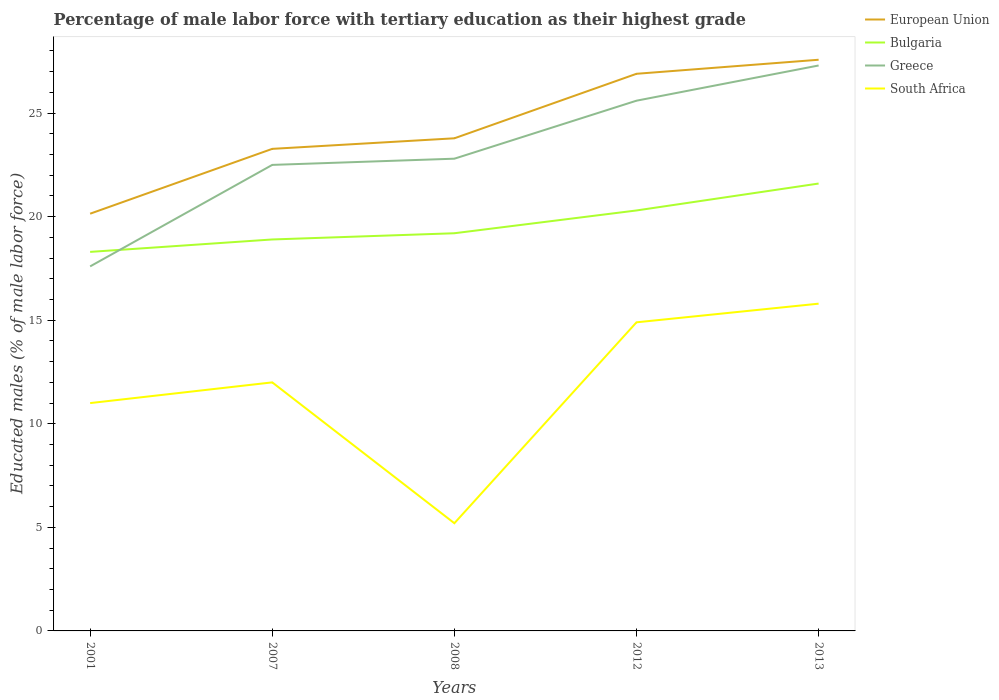How many different coloured lines are there?
Keep it short and to the point. 4. Across all years, what is the maximum percentage of male labor force with tertiary education in Greece?
Give a very brief answer. 17.6. In which year was the percentage of male labor force with tertiary education in Greece maximum?
Your answer should be compact. 2001. What is the total percentage of male labor force with tertiary education in European Union in the graph?
Provide a succinct answer. -6.75. What is the difference between the highest and the second highest percentage of male labor force with tertiary education in Greece?
Ensure brevity in your answer.  9.7. What is the difference between the highest and the lowest percentage of male labor force with tertiary education in European Union?
Offer a very short reply. 2. What is the title of the graph?
Your answer should be very brief. Percentage of male labor force with tertiary education as their highest grade. Does "Japan" appear as one of the legend labels in the graph?
Offer a very short reply. No. What is the label or title of the Y-axis?
Your response must be concise. Educated males (% of male labor force). What is the Educated males (% of male labor force) in European Union in 2001?
Ensure brevity in your answer.  20.14. What is the Educated males (% of male labor force) of Bulgaria in 2001?
Your answer should be very brief. 18.3. What is the Educated males (% of male labor force) of Greece in 2001?
Make the answer very short. 17.6. What is the Educated males (% of male labor force) of European Union in 2007?
Give a very brief answer. 23.27. What is the Educated males (% of male labor force) of Bulgaria in 2007?
Your response must be concise. 18.9. What is the Educated males (% of male labor force) in European Union in 2008?
Your answer should be very brief. 23.78. What is the Educated males (% of male labor force) of Bulgaria in 2008?
Keep it short and to the point. 19.2. What is the Educated males (% of male labor force) of Greece in 2008?
Offer a very short reply. 22.8. What is the Educated males (% of male labor force) in South Africa in 2008?
Keep it short and to the point. 5.2. What is the Educated males (% of male labor force) of European Union in 2012?
Provide a succinct answer. 26.9. What is the Educated males (% of male labor force) of Bulgaria in 2012?
Give a very brief answer. 20.3. What is the Educated males (% of male labor force) of Greece in 2012?
Keep it short and to the point. 25.6. What is the Educated males (% of male labor force) in South Africa in 2012?
Provide a succinct answer. 14.9. What is the Educated males (% of male labor force) of European Union in 2013?
Keep it short and to the point. 27.58. What is the Educated males (% of male labor force) in Bulgaria in 2013?
Offer a very short reply. 21.6. What is the Educated males (% of male labor force) in Greece in 2013?
Your answer should be very brief. 27.3. What is the Educated males (% of male labor force) of South Africa in 2013?
Provide a succinct answer. 15.8. Across all years, what is the maximum Educated males (% of male labor force) in European Union?
Give a very brief answer. 27.58. Across all years, what is the maximum Educated males (% of male labor force) of Bulgaria?
Make the answer very short. 21.6. Across all years, what is the maximum Educated males (% of male labor force) of Greece?
Your answer should be very brief. 27.3. Across all years, what is the maximum Educated males (% of male labor force) of South Africa?
Your answer should be very brief. 15.8. Across all years, what is the minimum Educated males (% of male labor force) of European Union?
Keep it short and to the point. 20.14. Across all years, what is the minimum Educated males (% of male labor force) of Bulgaria?
Provide a short and direct response. 18.3. Across all years, what is the minimum Educated males (% of male labor force) of Greece?
Provide a short and direct response. 17.6. Across all years, what is the minimum Educated males (% of male labor force) of South Africa?
Give a very brief answer. 5.2. What is the total Educated males (% of male labor force) in European Union in the graph?
Provide a short and direct response. 121.68. What is the total Educated males (% of male labor force) of Bulgaria in the graph?
Your answer should be very brief. 98.3. What is the total Educated males (% of male labor force) of Greece in the graph?
Keep it short and to the point. 115.8. What is the total Educated males (% of male labor force) in South Africa in the graph?
Make the answer very short. 58.9. What is the difference between the Educated males (% of male labor force) of European Union in 2001 and that in 2007?
Keep it short and to the point. -3.13. What is the difference between the Educated males (% of male labor force) in Bulgaria in 2001 and that in 2007?
Your response must be concise. -0.6. What is the difference between the Educated males (% of male labor force) of Greece in 2001 and that in 2007?
Provide a short and direct response. -4.9. What is the difference between the Educated males (% of male labor force) in South Africa in 2001 and that in 2007?
Your answer should be very brief. -1. What is the difference between the Educated males (% of male labor force) in European Union in 2001 and that in 2008?
Offer a terse response. -3.64. What is the difference between the Educated males (% of male labor force) in Greece in 2001 and that in 2008?
Your answer should be very brief. -5.2. What is the difference between the Educated males (% of male labor force) in South Africa in 2001 and that in 2008?
Your answer should be compact. 5.8. What is the difference between the Educated males (% of male labor force) of European Union in 2001 and that in 2012?
Your answer should be very brief. -6.75. What is the difference between the Educated males (% of male labor force) of Greece in 2001 and that in 2012?
Your response must be concise. -8. What is the difference between the Educated males (% of male labor force) of South Africa in 2001 and that in 2012?
Offer a very short reply. -3.9. What is the difference between the Educated males (% of male labor force) in European Union in 2001 and that in 2013?
Your answer should be very brief. -7.43. What is the difference between the Educated males (% of male labor force) in Bulgaria in 2001 and that in 2013?
Provide a succinct answer. -3.3. What is the difference between the Educated males (% of male labor force) of European Union in 2007 and that in 2008?
Your response must be concise. -0.51. What is the difference between the Educated males (% of male labor force) in Greece in 2007 and that in 2008?
Offer a very short reply. -0.3. What is the difference between the Educated males (% of male labor force) of European Union in 2007 and that in 2012?
Offer a very short reply. -3.62. What is the difference between the Educated males (% of male labor force) of Bulgaria in 2007 and that in 2012?
Offer a terse response. -1.4. What is the difference between the Educated males (% of male labor force) in Greece in 2007 and that in 2012?
Make the answer very short. -3.1. What is the difference between the Educated males (% of male labor force) in South Africa in 2007 and that in 2012?
Give a very brief answer. -2.9. What is the difference between the Educated males (% of male labor force) of European Union in 2007 and that in 2013?
Ensure brevity in your answer.  -4.3. What is the difference between the Educated males (% of male labor force) in Greece in 2007 and that in 2013?
Offer a terse response. -4.8. What is the difference between the Educated males (% of male labor force) of South Africa in 2007 and that in 2013?
Provide a short and direct response. -3.8. What is the difference between the Educated males (% of male labor force) in European Union in 2008 and that in 2012?
Make the answer very short. -3.11. What is the difference between the Educated males (% of male labor force) of Bulgaria in 2008 and that in 2012?
Your answer should be very brief. -1.1. What is the difference between the Educated males (% of male labor force) of South Africa in 2008 and that in 2012?
Make the answer very short. -9.7. What is the difference between the Educated males (% of male labor force) of European Union in 2008 and that in 2013?
Provide a succinct answer. -3.79. What is the difference between the Educated males (% of male labor force) in Bulgaria in 2008 and that in 2013?
Give a very brief answer. -2.4. What is the difference between the Educated males (% of male labor force) in European Union in 2012 and that in 2013?
Keep it short and to the point. -0.68. What is the difference between the Educated males (% of male labor force) in Bulgaria in 2012 and that in 2013?
Ensure brevity in your answer.  -1.3. What is the difference between the Educated males (% of male labor force) in South Africa in 2012 and that in 2013?
Keep it short and to the point. -0.9. What is the difference between the Educated males (% of male labor force) of European Union in 2001 and the Educated males (% of male labor force) of Bulgaria in 2007?
Provide a succinct answer. 1.24. What is the difference between the Educated males (% of male labor force) of European Union in 2001 and the Educated males (% of male labor force) of Greece in 2007?
Ensure brevity in your answer.  -2.36. What is the difference between the Educated males (% of male labor force) in European Union in 2001 and the Educated males (% of male labor force) in South Africa in 2007?
Provide a succinct answer. 8.14. What is the difference between the Educated males (% of male labor force) of Bulgaria in 2001 and the Educated males (% of male labor force) of Greece in 2007?
Your answer should be very brief. -4.2. What is the difference between the Educated males (% of male labor force) in European Union in 2001 and the Educated males (% of male labor force) in Bulgaria in 2008?
Provide a succinct answer. 0.94. What is the difference between the Educated males (% of male labor force) in European Union in 2001 and the Educated males (% of male labor force) in Greece in 2008?
Your answer should be compact. -2.66. What is the difference between the Educated males (% of male labor force) in European Union in 2001 and the Educated males (% of male labor force) in South Africa in 2008?
Your answer should be compact. 14.94. What is the difference between the Educated males (% of male labor force) of Greece in 2001 and the Educated males (% of male labor force) of South Africa in 2008?
Your answer should be very brief. 12.4. What is the difference between the Educated males (% of male labor force) of European Union in 2001 and the Educated males (% of male labor force) of Bulgaria in 2012?
Provide a succinct answer. -0.16. What is the difference between the Educated males (% of male labor force) of European Union in 2001 and the Educated males (% of male labor force) of Greece in 2012?
Your answer should be very brief. -5.46. What is the difference between the Educated males (% of male labor force) in European Union in 2001 and the Educated males (% of male labor force) in South Africa in 2012?
Offer a terse response. 5.24. What is the difference between the Educated males (% of male labor force) in European Union in 2001 and the Educated males (% of male labor force) in Bulgaria in 2013?
Your response must be concise. -1.46. What is the difference between the Educated males (% of male labor force) in European Union in 2001 and the Educated males (% of male labor force) in Greece in 2013?
Offer a very short reply. -7.16. What is the difference between the Educated males (% of male labor force) of European Union in 2001 and the Educated males (% of male labor force) of South Africa in 2013?
Your answer should be very brief. 4.34. What is the difference between the Educated males (% of male labor force) of Bulgaria in 2001 and the Educated males (% of male labor force) of South Africa in 2013?
Provide a short and direct response. 2.5. What is the difference between the Educated males (% of male labor force) in Greece in 2001 and the Educated males (% of male labor force) in South Africa in 2013?
Offer a very short reply. 1.8. What is the difference between the Educated males (% of male labor force) of European Union in 2007 and the Educated males (% of male labor force) of Bulgaria in 2008?
Keep it short and to the point. 4.07. What is the difference between the Educated males (% of male labor force) of European Union in 2007 and the Educated males (% of male labor force) of Greece in 2008?
Make the answer very short. 0.47. What is the difference between the Educated males (% of male labor force) of European Union in 2007 and the Educated males (% of male labor force) of South Africa in 2008?
Offer a terse response. 18.07. What is the difference between the Educated males (% of male labor force) in Bulgaria in 2007 and the Educated males (% of male labor force) in Greece in 2008?
Your answer should be compact. -3.9. What is the difference between the Educated males (% of male labor force) in European Union in 2007 and the Educated males (% of male labor force) in Bulgaria in 2012?
Give a very brief answer. 2.97. What is the difference between the Educated males (% of male labor force) in European Union in 2007 and the Educated males (% of male labor force) in Greece in 2012?
Offer a very short reply. -2.33. What is the difference between the Educated males (% of male labor force) of European Union in 2007 and the Educated males (% of male labor force) of South Africa in 2012?
Keep it short and to the point. 8.37. What is the difference between the Educated males (% of male labor force) of European Union in 2007 and the Educated males (% of male labor force) of Bulgaria in 2013?
Provide a short and direct response. 1.67. What is the difference between the Educated males (% of male labor force) of European Union in 2007 and the Educated males (% of male labor force) of Greece in 2013?
Provide a short and direct response. -4.03. What is the difference between the Educated males (% of male labor force) of European Union in 2007 and the Educated males (% of male labor force) of South Africa in 2013?
Offer a terse response. 7.47. What is the difference between the Educated males (% of male labor force) in Bulgaria in 2007 and the Educated males (% of male labor force) in Greece in 2013?
Make the answer very short. -8.4. What is the difference between the Educated males (% of male labor force) in Bulgaria in 2007 and the Educated males (% of male labor force) in South Africa in 2013?
Provide a succinct answer. 3.1. What is the difference between the Educated males (% of male labor force) in European Union in 2008 and the Educated males (% of male labor force) in Bulgaria in 2012?
Offer a very short reply. 3.48. What is the difference between the Educated males (% of male labor force) in European Union in 2008 and the Educated males (% of male labor force) in Greece in 2012?
Make the answer very short. -1.82. What is the difference between the Educated males (% of male labor force) in European Union in 2008 and the Educated males (% of male labor force) in South Africa in 2012?
Make the answer very short. 8.88. What is the difference between the Educated males (% of male labor force) in Bulgaria in 2008 and the Educated males (% of male labor force) in South Africa in 2012?
Ensure brevity in your answer.  4.3. What is the difference between the Educated males (% of male labor force) of Greece in 2008 and the Educated males (% of male labor force) of South Africa in 2012?
Offer a terse response. 7.9. What is the difference between the Educated males (% of male labor force) of European Union in 2008 and the Educated males (% of male labor force) of Bulgaria in 2013?
Your answer should be compact. 2.18. What is the difference between the Educated males (% of male labor force) in European Union in 2008 and the Educated males (% of male labor force) in Greece in 2013?
Your response must be concise. -3.52. What is the difference between the Educated males (% of male labor force) of European Union in 2008 and the Educated males (% of male labor force) of South Africa in 2013?
Offer a very short reply. 7.98. What is the difference between the Educated males (% of male labor force) of Bulgaria in 2008 and the Educated males (% of male labor force) of South Africa in 2013?
Ensure brevity in your answer.  3.4. What is the difference between the Educated males (% of male labor force) of European Union in 2012 and the Educated males (% of male labor force) of Bulgaria in 2013?
Provide a succinct answer. 5.3. What is the difference between the Educated males (% of male labor force) of European Union in 2012 and the Educated males (% of male labor force) of Greece in 2013?
Give a very brief answer. -0.4. What is the difference between the Educated males (% of male labor force) of European Union in 2012 and the Educated males (% of male labor force) of South Africa in 2013?
Your response must be concise. 11.1. What is the difference between the Educated males (% of male labor force) in Bulgaria in 2012 and the Educated males (% of male labor force) in South Africa in 2013?
Your answer should be very brief. 4.5. What is the average Educated males (% of male labor force) of European Union per year?
Your response must be concise. 24.34. What is the average Educated males (% of male labor force) in Bulgaria per year?
Offer a very short reply. 19.66. What is the average Educated males (% of male labor force) in Greece per year?
Make the answer very short. 23.16. What is the average Educated males (% of male labor force) in South Africa per year?
Provide a short and direct response. 11.78. In the year 2001, what is the difference between the Educated males (% of male labor force) in European Union and Educated males (% of male labor force) in Bulgaria?
Offer a very short reply. 1.84. In the year 2001, what is the difference between the Educated males (% of male labor force) in European Union and Educated males (% of male labor force) in Greece?
Offer a very short reply. 2.54. In the year 2001, what is the difference between the Educated males (% of male labor force) of European Union and Educated males (% of male labor force) of South Africa?
Your answer should be compact. 9.14. In the year 2007, what is the difference between the Educated males (% of male labor force) of European Union and Educated males (% of male labor force) of Bulgaria?
Offer a very short reply. 4.37. In the year 2007, what is the difference between the Educated males (% of male labor force) in European Union and Educated males (% of male labor force) in Greece?
Offer a terse response. 0.77. In the year 2007, what is the difference between the Educated males (% of male labor force) of European Union and Educated males (% of male labor force) of South Africa?
Provide a succinct answer. 11.27. In the year 2007, what is the difference between the Educated males (% of male labor force) of Bulgaria and Educated males (% of male labor force) of Greece?
Give a very brief answer. -3.6. In the year 2007, what is the difference between the Educated males (% of male labor force) in Bulgaria and Educated males (% of male labor force) in South Africa?
Offer a very short reply. 6.9. In the year 2007, what is the difference between the Educated males (% of male labor force) in Greece and Educated males (% of male labor force) in South Africa?
Your response must be concise. 10.5. In the year 2008, what is the difference between the Educated males (% of male labor force) in European Union and Educated males (% of male labor force) in Bulgaria?
Keep it short and to the point. 4.58. In the year 2008, what is the difference between the Educated males (% of male labor force) in European Union and Educated males (% of male labor force) in Greece?
Your answer should be very brief. 0.98. In the year 2008, what is the difference between the Educated males (% of male labor force) of European Union and Educated males (% of male labor force) of South Africa?
Provide a succinct answer. 18.58. In the year 2008, what is the difference between the Educated males (% of male labor force) in Bulgaria and Educated males (% of male labor force) in Greece?
Provide a short and direct response. -3.6. In the year 2012, what is the difference between the Educated males (% of male labor force) of European Union and Educated males (% of male labor force) of Bulgaria?
Offer a very short reply. 6.6. In the year 2012, what is the difference between the Educated males (% of male labor force) in European Union and Educated males (% of male labor force) in Greece?
Your answer should be compact. 1.3. In the year 2012, what is the difference between the Educated males (% of male labor force) in European Union and Educated males (% of male labor force) in South Africa?
Provide a succinct answer. 12. In the year 2012, what is the difference between the Educated males (% of male labor force) in Greece and Educated males (% of male labor force) in South Africa?
Give a very brief answer. 10.7. In the year 2013, what is the difference between the Educated males (% of male labor force) of European Union and Educated males (% of male labor force) of Bulgaria?
Offer a very short reply. 5.98. In the year 2013, what is the difference between the Educated males (% of male labor force) of European Union and Educated males (% of male labor force) of Greece?
Provide a short and direct response. 0.28. In the year 2013, what is the difference between the Educated males (% of male labor force) of European Union and Educated males (% of male labor force) of South Africa?
Make the answer very short. 11.78. In the year 2013, what is the difference between the Educated males (% of male labor force) of Bulgaria and Educated males (% of male labor force) of South Africa?
Offer a very short reply. 5.8. What is the ratio of the Educated males (% of male labor force) in European Union in 2001 to that in 2007?
Provide a succinct answer. 0.87. What is the ratio of the Educated males (% of male labor force) in Bulgaria in 2001 to that in 2007?
Your answer should be compact. 0.97. What is the ratio of the Educated males (% of male labor force) of Greece in 2001 to that in 2007?
Provide a short and direct response. 0.78. What is the ratio of the Educated males (% of male labor force) in South Africa in 2001 to that in 2007?
Your response must be concise. 0.92. What is the ratio of the Educated males (% of male labor force) of European Union in 2001 to that in 2008?
Your answer should be compact. 0.85. What is the ratio of the Educated males (% of male labor force) in Bulgaria in 2001 to that in 2008?
Offer a very short reply. 0.95. What is the ratio of the Educated males (% of male labor force) in Greece in 2001 to that in 2008?
Your answer should be compact. 0.77. What is the ratio of the Educated males (% of male labor force) in South Africa in 2001 to that in 2008?
Offer a very short reply. 2.12. What is the ratio of the Educated males (% of male labor force) in European Union in 2001 to that in 2012?
Your answer should be very brief. 0.75. What is the ratio of the Educated males (% of male labor force) of Bulgaria in 2001 to that in 2012?
Keep it short and to the point. 0.9. What is the ratio of the Educated males (% of male labor force) of Greece in 2001 to that in 2012?
Your answer should be compact. 0.69. What is the ratio of the Educated males (% of male labor force) in South Africa in 2001 to that in 2012?
Your answer should be compact. 0.74. What is the ratio of the Educated males (% of male labor force) in European Union in 2001 to that in 2013?
Provide a succinct answer. 0.73. What is the ratio of the Educated males (% of male labor force) of Bulgaria in 2001 to that in 2013?
Your response must be concise. 0.85. What is the ratio of the Educated males (% of male labor force) of Greece in 2001 to that in 2013?
Offer a terse response. 0.64. What is the ratio of the Educated males (% of male labor force) of South Africa in 2001 to that in 2013?
Your answer should be compact. 0.7. What is the ratio of the Educated males (% of male labor force) in European Union in 2007 to that in 2008?
Offer a very short reply. 0.98. What is the ratio of the Educated males (% of male labor force) in Bulgaria in 2007 to that in 2008?
Your answer should be very brief. 0.98. What is the ratio of the Educated males (% of male labor force) in South Africa in 2007 to that in 2008?
Give a very brief answer. 2.31. What is the ratio of the Educated males (% of male labor force) in European Union in 2007 to that in 2012?
Ensure brevity in your answer.  0.87. What is the ratio of the Educated males (% of male labor force) of Bulgaria in 2007 to that in 2012?
Ensure brevity in your answer.  0.93. What is the ratio of the Educated males (% of male labor force) in Greece in 2007 to that in 2012?
Offer a terse response. 0.88. What is the ratio of the Educated males (% of male labor force) of South Africa in 2007 to that in 2012?
Give a very brief answer. 0.81. What is the ratio of the Educated males (% of male labor force) in European Union in 2007 to that in 2013?
Your answer should be very brief. 0.84. What is the ratio of the Educated males (% of male labor force) of Greece in 2007 to that in 2013?
Make the answer very short. 0.82. What is the ratio of the Educated males (% of male labor force) in South Africa in 2007 to that in 2013?
Keep it short and to the point. 0.76. What is the ratio of the Educated males (% of male labor force) of European Union in 2008 to that in 2012?
Offer a terse response. 0.88. What is the ratio of the Educated males (% of male labor force) in Bulgaria in 2008 to that in 2012?
Offer a terse response. 0.95. What is the ratio of the Educated males (% of male labor force) in Greece in 2008 to that in 2012?
Your response must be concise. 0.89. What is the ratio of the Educated males (% of male labor force) in South Africa in 2008 to that in 2012?
Your answer should be compact. 0.35. What is the ratio of the Educated males (% of male labor force) in European Union in 2008 to that in 2013?
Give a very brief answer. 0.86. What is the ratio of the Educated males (% of male labor force) in Greece in 2008 to that in 2013?
Offer a very short reply. 0.84. What is the ratio of the Educated males (% of male labor force) of South Africa in 2008 to that in 2013?
Provide a short and direct response. 0.33. What is the ratio of the Educated males (% of male labor force) of European Union in 2012 to that in 2013?
Your answer should be compact. 0.98. What is the ratio of the Educated males (% of male labor force) of Bulgaria in 2012 to that in 2013?
Provide a short and direct response. 0.94. What is the ratio of the Educated males (% of male labor force) of Greece in 2012 to that in 2013?
Ensure brevity in your answer.  0.94. What is the ratio of the Educated males (% of male labor force) in South Africa in 2012 to that in 2013?
Make the answer very short. 0.94. What is the difference between the highest and the second highest Educated males (% of male labor force) of European Union?
Offer a terse response. 0.68. What is the difference between the highest and the second highest Educated males (% of male labor force) of South Africa?
Make the answer very short. 0.9. What is the difference between the highest and the lowest Educated males (% of male labor force) in European Union?
Offer a terse response. 7.43. What is the difference between the highest and the lowest Educated males (% of male labor force) of Bulgaria?
Provide a short and direct response. 3.3. What is the difference between the highest and the lowest Educated males (% of male labor force) of Greece?
Ensure brevity in your answer.  9.7. What is the difference between the highest and the lowest Educated males (% of male labor force) in South Africa?
Offer a very short reply. 10.6. 